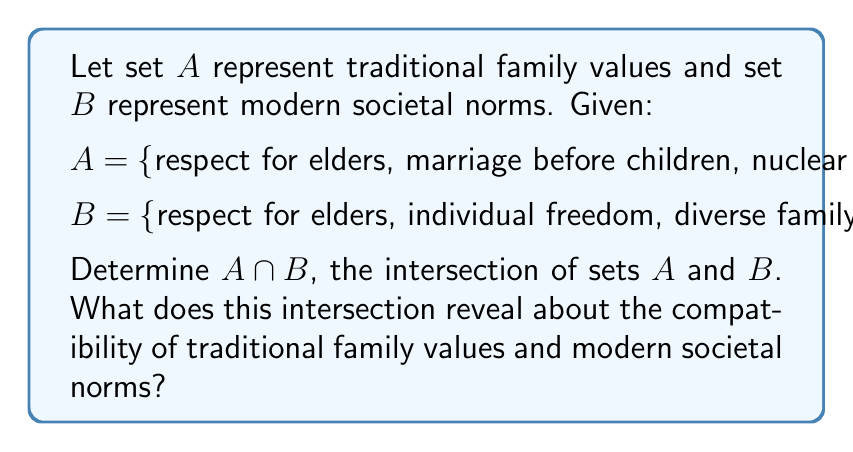Provide a solution to this math problem. To find the intersection of sets $A$ and $B$, we need to identify the elements that are common to both sets. Let's examine each element:

1. "respect for elders" is present in both $A$ and $B$
2. "marriage before children" is only in $A$
3. "nuclear family structure" is only in $A$
4. "gender-specific roles" is only in $A$
5. "religious observance" is only in $A$
6. "individual freedom" is only in $B$
7. "diverse family structures" is only in $B$
8. "gender equality" is only in $B$
9. "secular lifestyle" is only in $B$

The only element that appears in both sets is "respect for elders".

Therefore, $A \cap B = \{$respect for elders$\}$

This intersection reveals that there is minimal overlap between traditional family values and modern societal norms as represented by these sets. The only common ground is the value of respecting elders, which has persisted from traditional values into modern norms. This suggests that there may be significant tension between traditional family values and modern societal norms, as they share very few common elements in this representation.
Answer: $A \cap B = \{$respect for elders$\}$ 